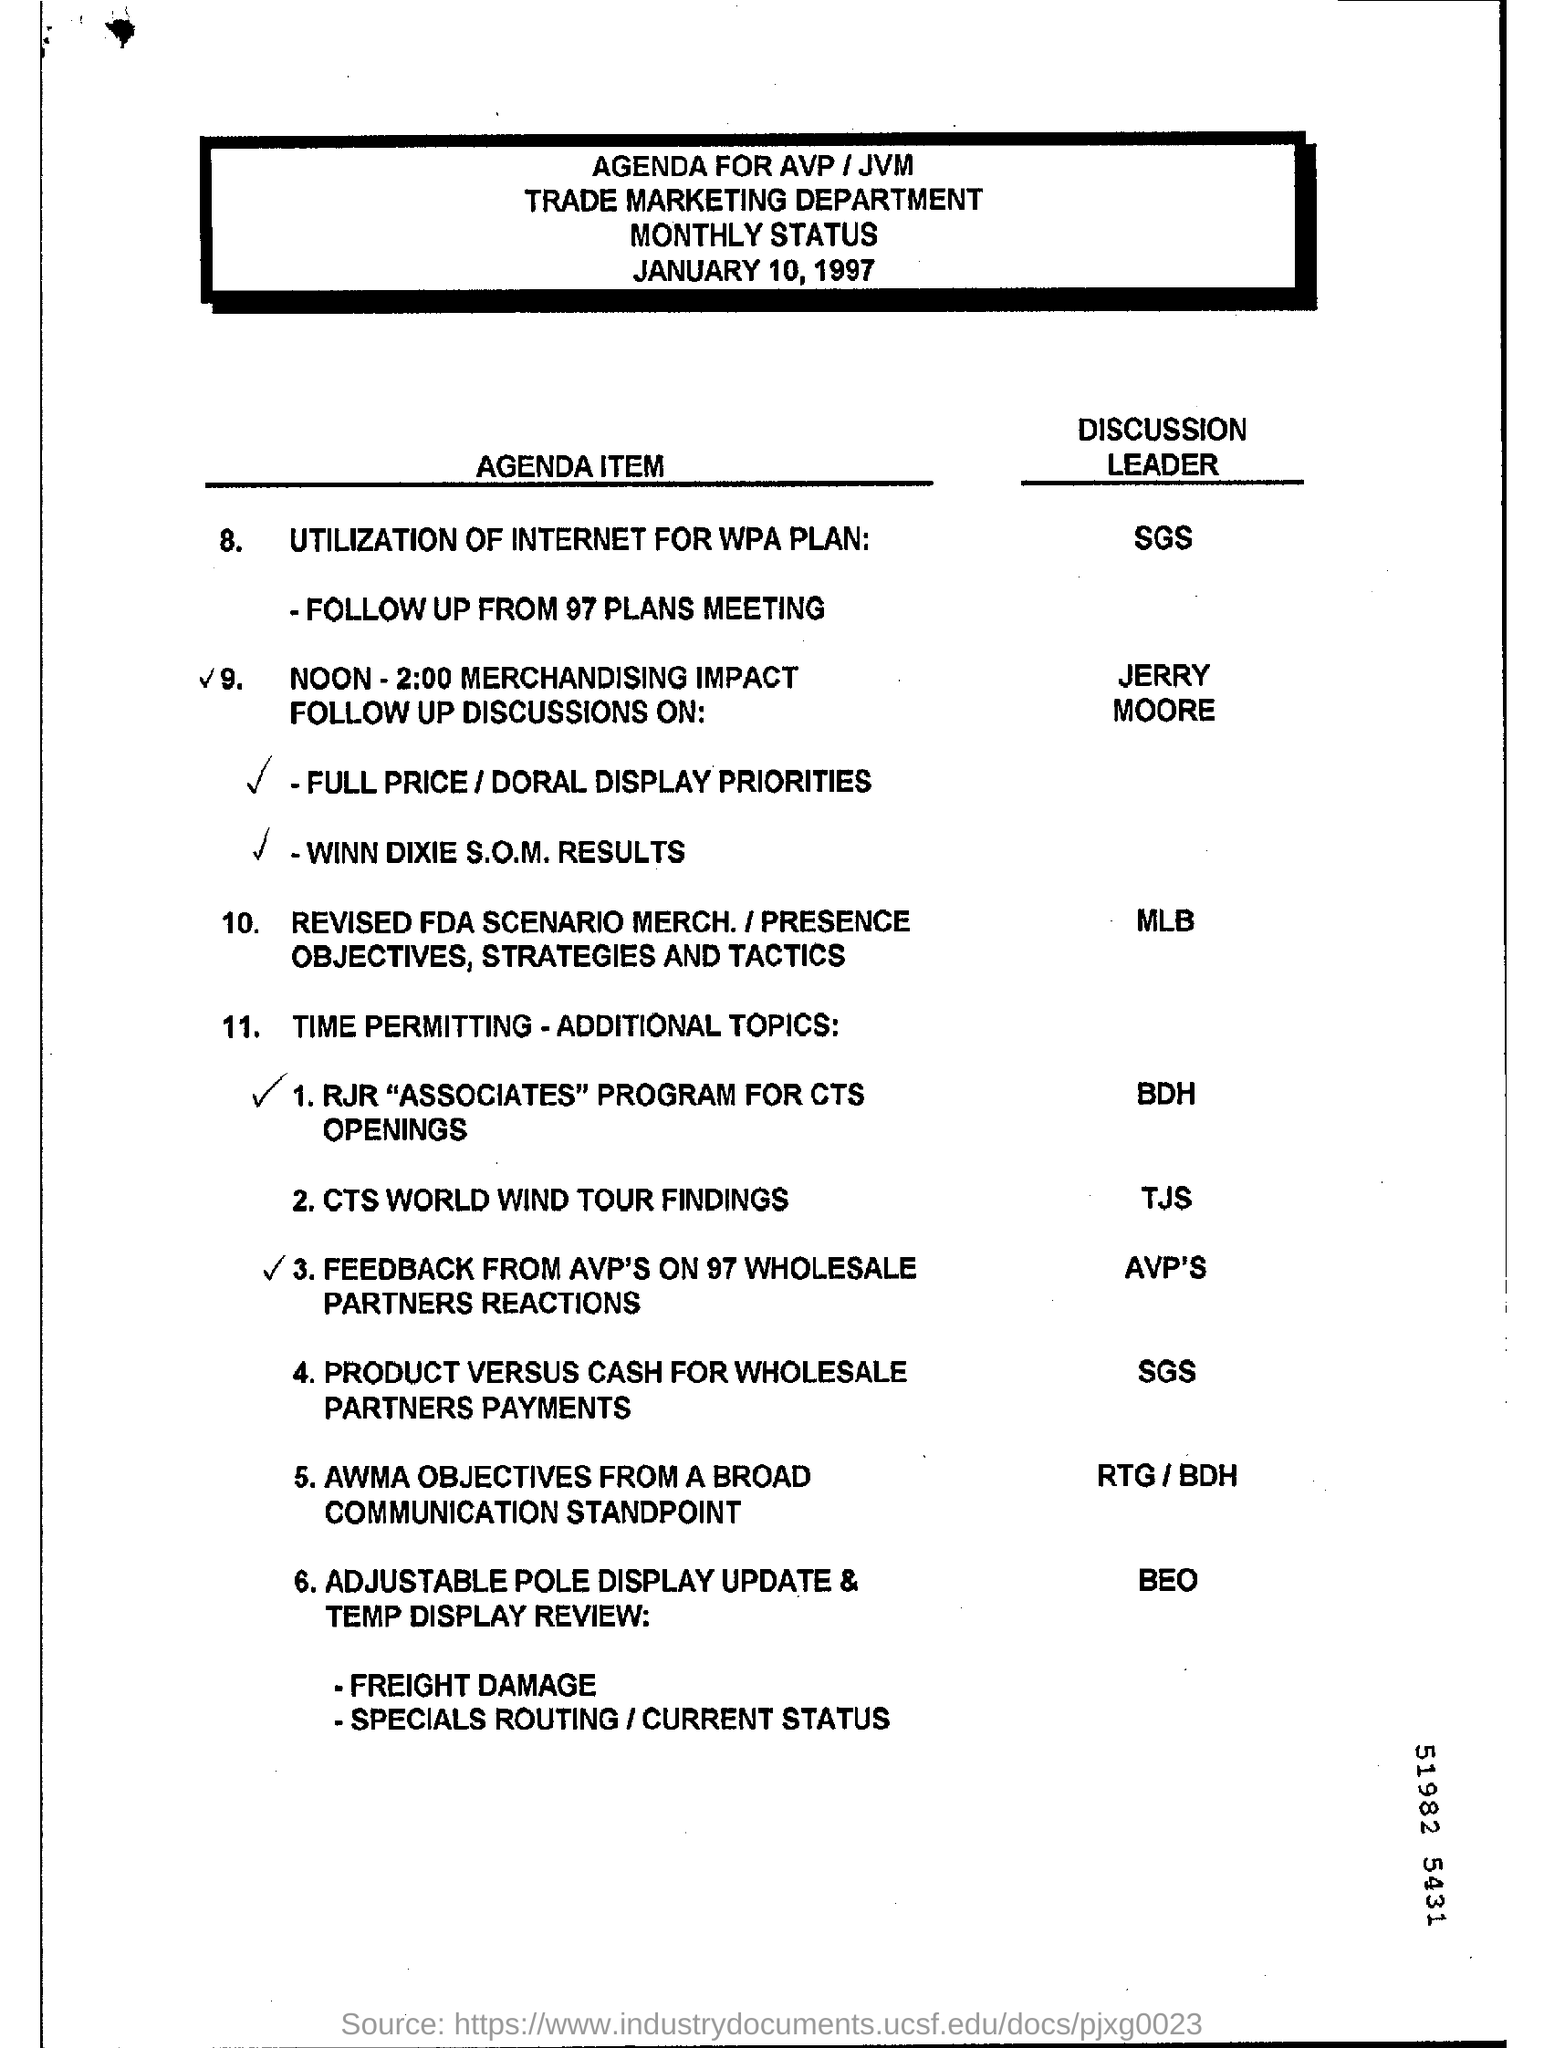Who is the discussion leader for utilization of internet for wpa plan?
Give a very brief answer. SGS. What is the marketing department?
Keep it short and to the point. Trade. 